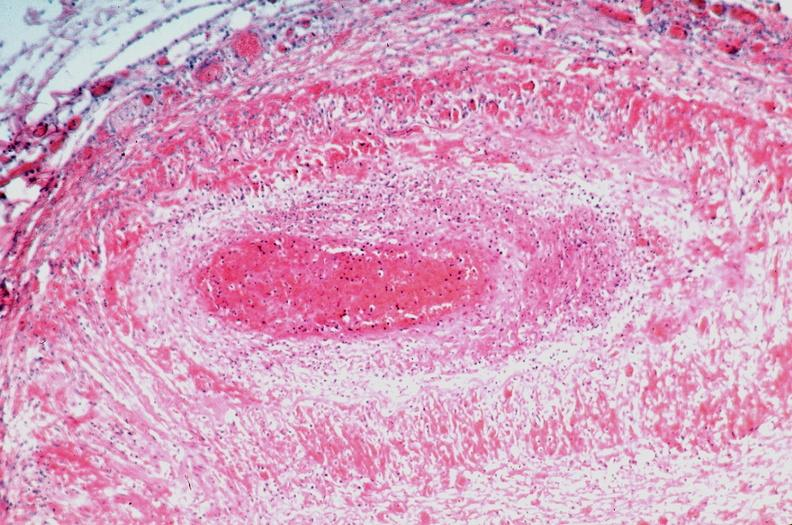what does this image show?
Answer the question using a single word or phrase. Vasculitis 